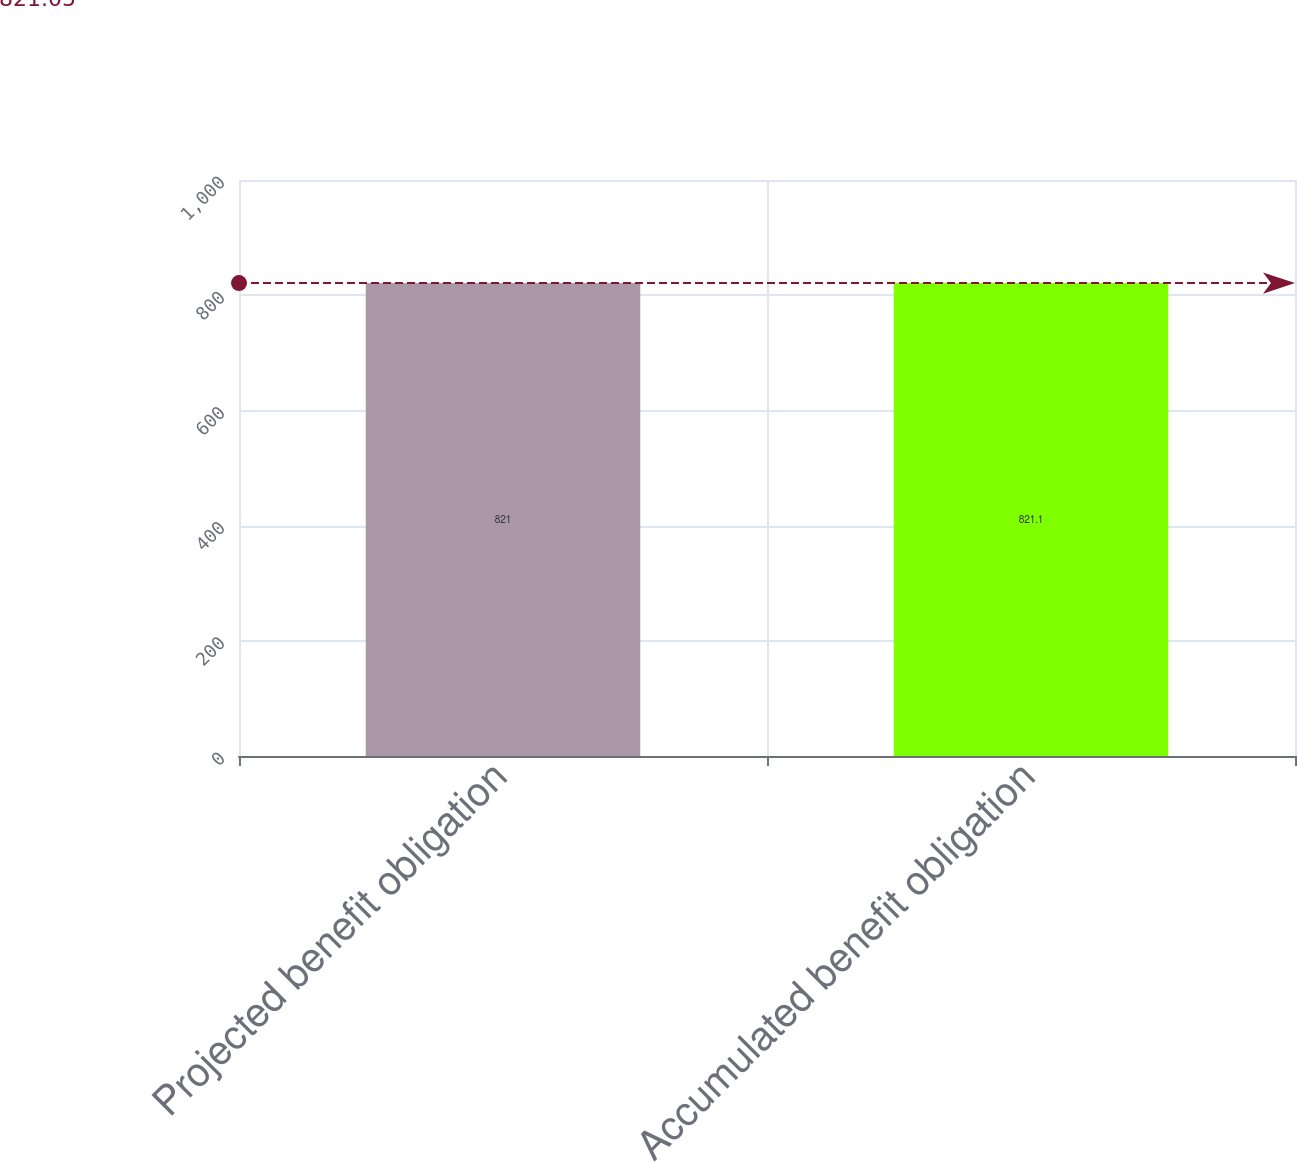<chart> <loc_0><loc_0><loc_500><loc_500><bar_chart><fcel>Projected benefit obligation<fcel>Accumulated benefit obligation<nl><fcel>821<fcel>821.1<nl></chart> 